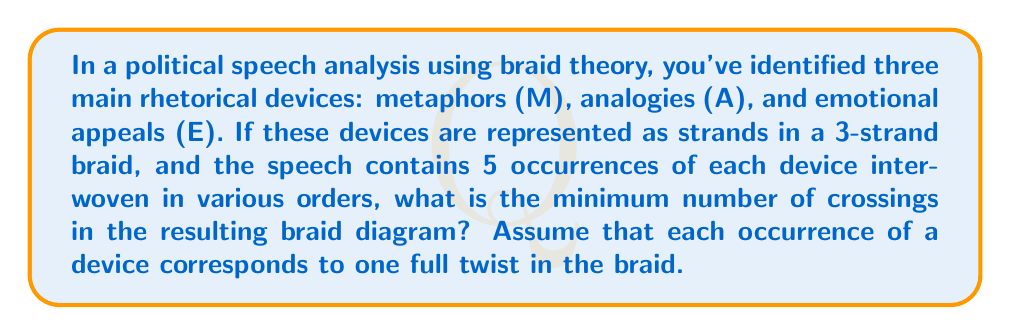Provide a solution to this math problem. To solve this problem, we'll follow these steps:

1) First, recall that in a standard 3-strand braid, one full twist consists of 3 crossings.

2) We're told that there are 5 occurrences of each device, and each occurrence corresponds to one full twist.

3) Therefore, the total number of full twists in the braid is:

   $$ 5 + 5 + 5 = 15 $$

4) Now, we can calculate the total number of crossings:

   $$ 15 \text{ twists} \times 3 \text{ crossings per twist} = 45 \text{ crossings} $$

5) This represents the minimum number of crossings because we're assuming the most efficient braiding pattern without any unnecessary crossings.

6) In braid theory notation, this braid could be represented as:

   $$ (\sigma_1 \sigma_2 \sigma_1)^{15} $$

   where $\sigma_1$ and $\sigma_2$ represent the standard generators of the braid group $B_3$.

7) This braid diagram would visually represent how the three rhetorical devices (M, A, E) intertwine throughout the speech, with each crossing indicating a transition or interaction between devices.
Answer: 45 crossings 